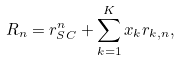<formula> <loc_0><loc_0><loc_500><loc_500>R _ { n } = r ^ { n } _ { S C } + \sum _ { k = 1 } ^ { K } x _ { k } r _ { k , n } ,</formula> 